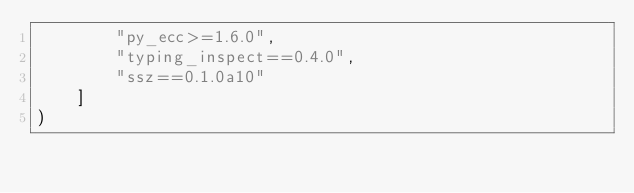Convert code to text. <code><loc_0><loc_0><loc_500><loc_500><_Python_>        "py_ecc>=1.6.0",
        "typing_inspect==0.4.0",
        "ssz==0.1.0a10"
    ]
)
</code> 